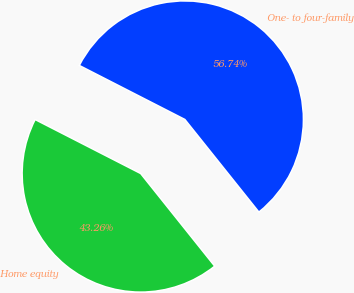Convert chart. <chart><loc_0><loc_0><loc_500><loc_500><pie_chart><fcel>One- to four-family<fcel>Home equity<nl><fcel>56.74%<fcel>43.26%<nl></chart> 